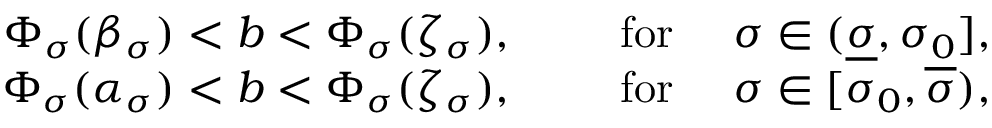<formula> <loc_0><loc_0><loc_500><loc_500>\begin{array} { r } { \Phi _ { \sigma } ( \beta _ { \sigma } ) < b < \Phi _ { \sigma } ( \zeta _ { \sigma } ) , \quad f o r \quad \sigma \in ( \underline { \sigma } , \sigma _ { 0 } ] , } \\ { \Phi _ { \sigma } ( \alpha _ { \sigma } ) < b < \Phi _ { \sigma } ( \zeta _ { \sigma } ) , \quad f o r \quad \sigma \in [ \sigma _ { 0 } , \overline { \sigma } ) , } \end{array}</formula> 